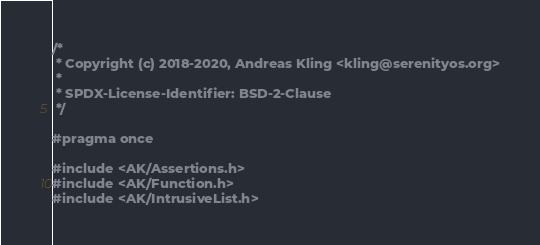<code> <loc_0><loc_0><loc_500><loc_500><_C_>/*
 * Copyright (c) 2018-2020, Andreas Kling <kling@serenityos.org>
 *
 * SPDX-License-Identifier: BSD-2-Clause
 */

#pragma once

#include <AK/Assertions.h>
#include <AK/Function.h>
#include <AK/IntrusiveList.h></code> 